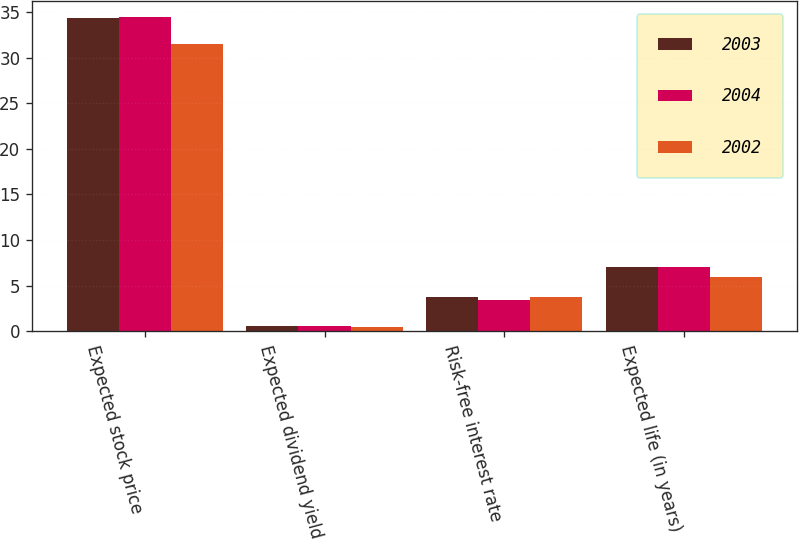Convert chart to OTSL. <chart><loc_0><loc_0><loc_500><loc_500><stacked_bar_chart><ecel><fcel>Expected stock price<fcel>Expected dividend yield<fcel>Risk-free interest rate<fcel>Expected life (in years)<nl><fcel>2003<fcel>34.3<fcel>0.59<fcel>3.8<fcel>7<nl><fcel>2004<fcel>34.5<fcel>0.59<fcel>3.4<fcel>7<nl><fcel>2002<fcel>31.5<fcel>0.52<fcel>3.8<fcel>6<nl></chart> 